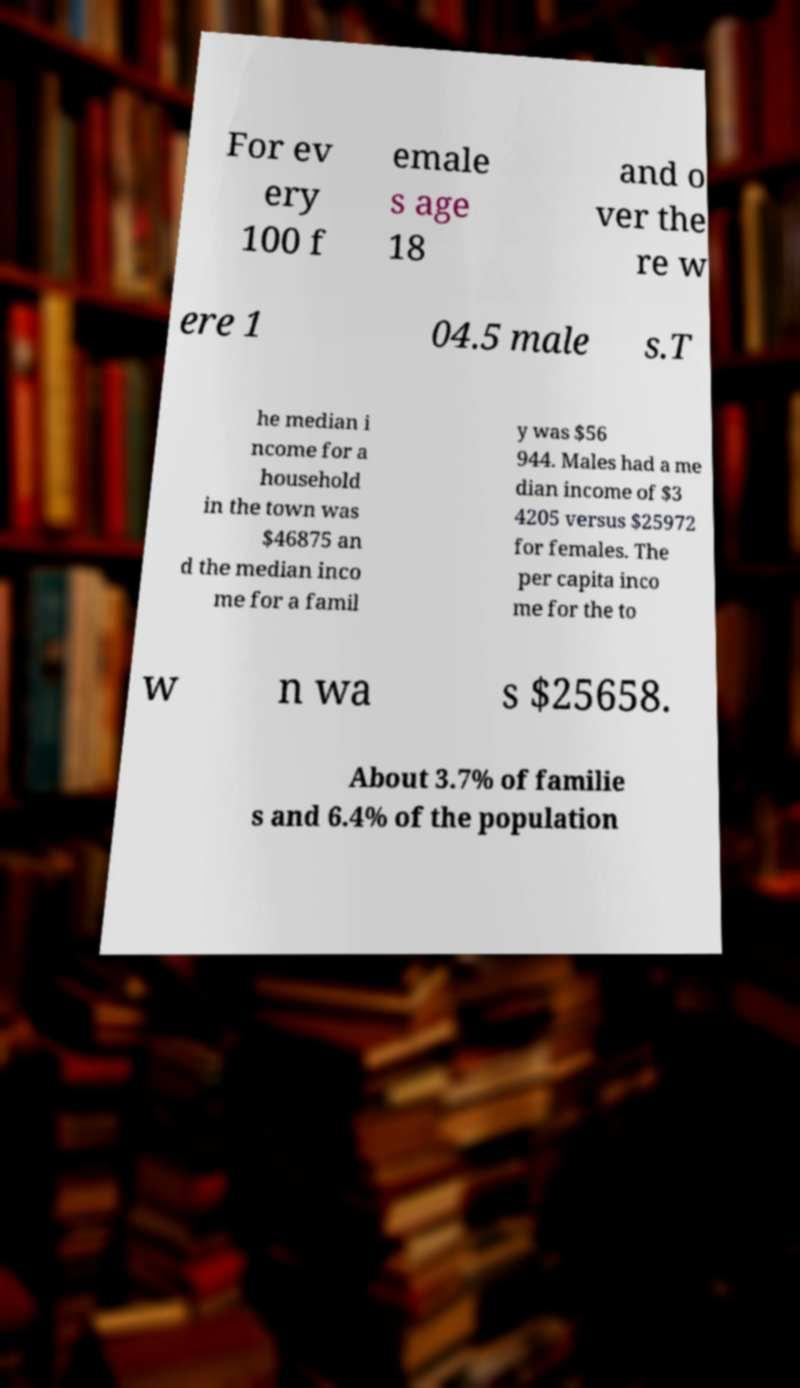I need the written content from this picture converted into text. Can you do that? For ev ery 100 f emale s age 18 and o ver the re w ere 1 04.5 male s.T he median i ncome for a household in the town was $46875 an d the median inco me for a famil y was $56 944. Males had a me dian income of $3 4205 versus $25972 for females. The per capita inco me for the to w n wa s $25658. About 3.7% of familie s and 6.4% of the population 